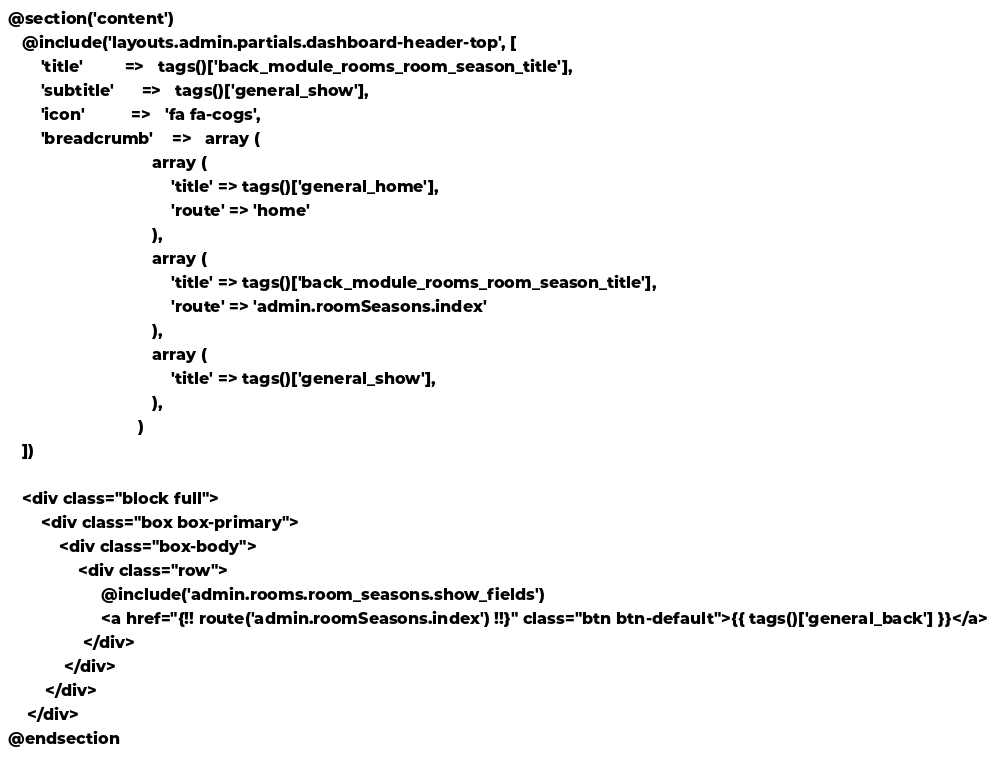<code> <loc_0><loc_0><loc_500><loc_500><_PHP_>
@section('content')
   @include('layouts.admin.partials.dashboard-header-top', [
       'title'         =>   tags()['back_module_rooms_room_season_title'],
       'subtitle'      =>   tags()['general_show'],
       'icon'          =>   'fa fa-cogs',
       'breadcrumb'    =>   array (
                               array (
                                   'title' => tags()['general_home'],
                                   'route' => 'home'
                               ),
                               array (
                                   'title' => tags()['back_module_rooms_room_season_title'],
                                   'route' => 'admin.roomSeasons.index'
                               ),
                               array (
                                   'title' => tags()['general_show'],
                               ),
                            )
   ])

   <div class="block full">
       <div class="box box-primary">
           <div class="box-body">
               <div class="row">
                    @include('admin.rooms.room_seasons.show_fields')
                    <a href="{!! route('admin.roomSeasons.index') !!}" class="btn btn-default">{{ tags()['general_back'] }}</a>
                </div>
            </div>
        </div>
    </div>
@endsection
</code> 